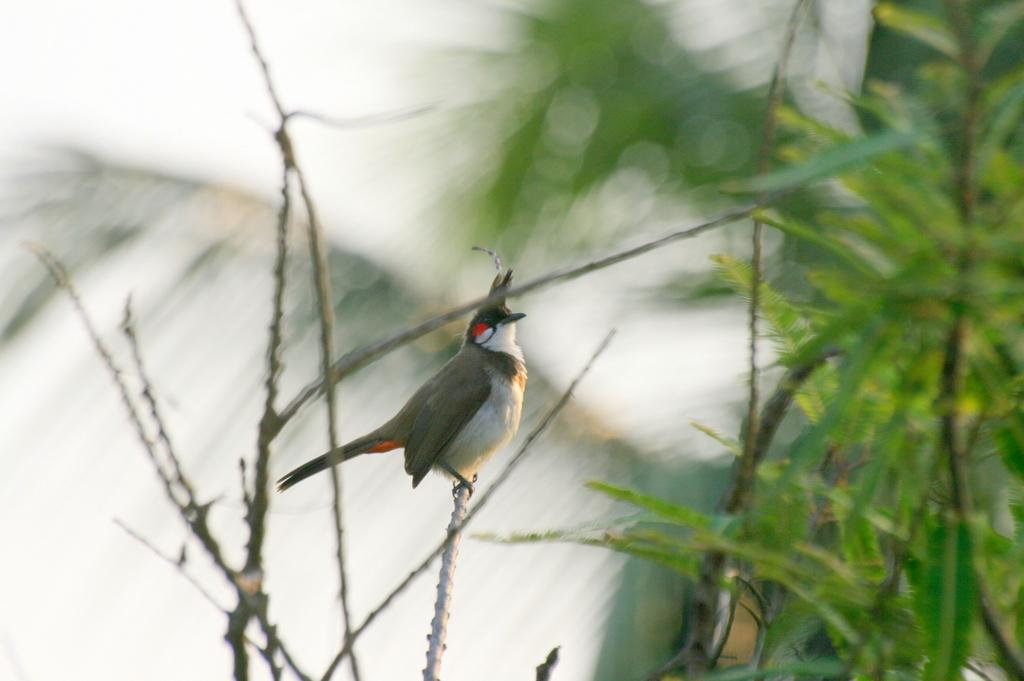What type of animal is in the image? There is a bird in the image. What is the bird standing on? The bird is standing on an iron rod. What can be seen in the background of the image? There are trees in the background of the image. How many girls are playing in the snow in the image? There are no girls or snow present in the image; it features a bird standing on an iron rod with trees in the background. 